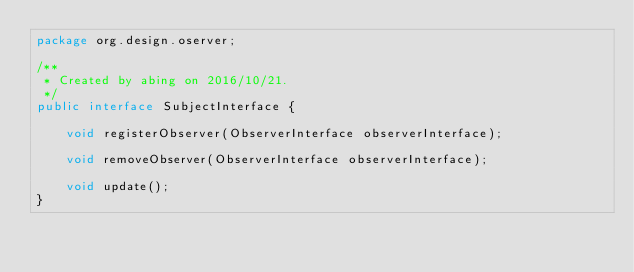<code> <loc_0><loc_0><loc_500><loc_500><_Java_>package org.design.oserver;

/**
 * Created by abing on 2016/10/21.
 */
public interface SubjectInterface {

    void registerObserver(ObserverInterface observerInterface);

    void removeObserver(ObserverInterface observerInterface);

    void update();
}</code> 